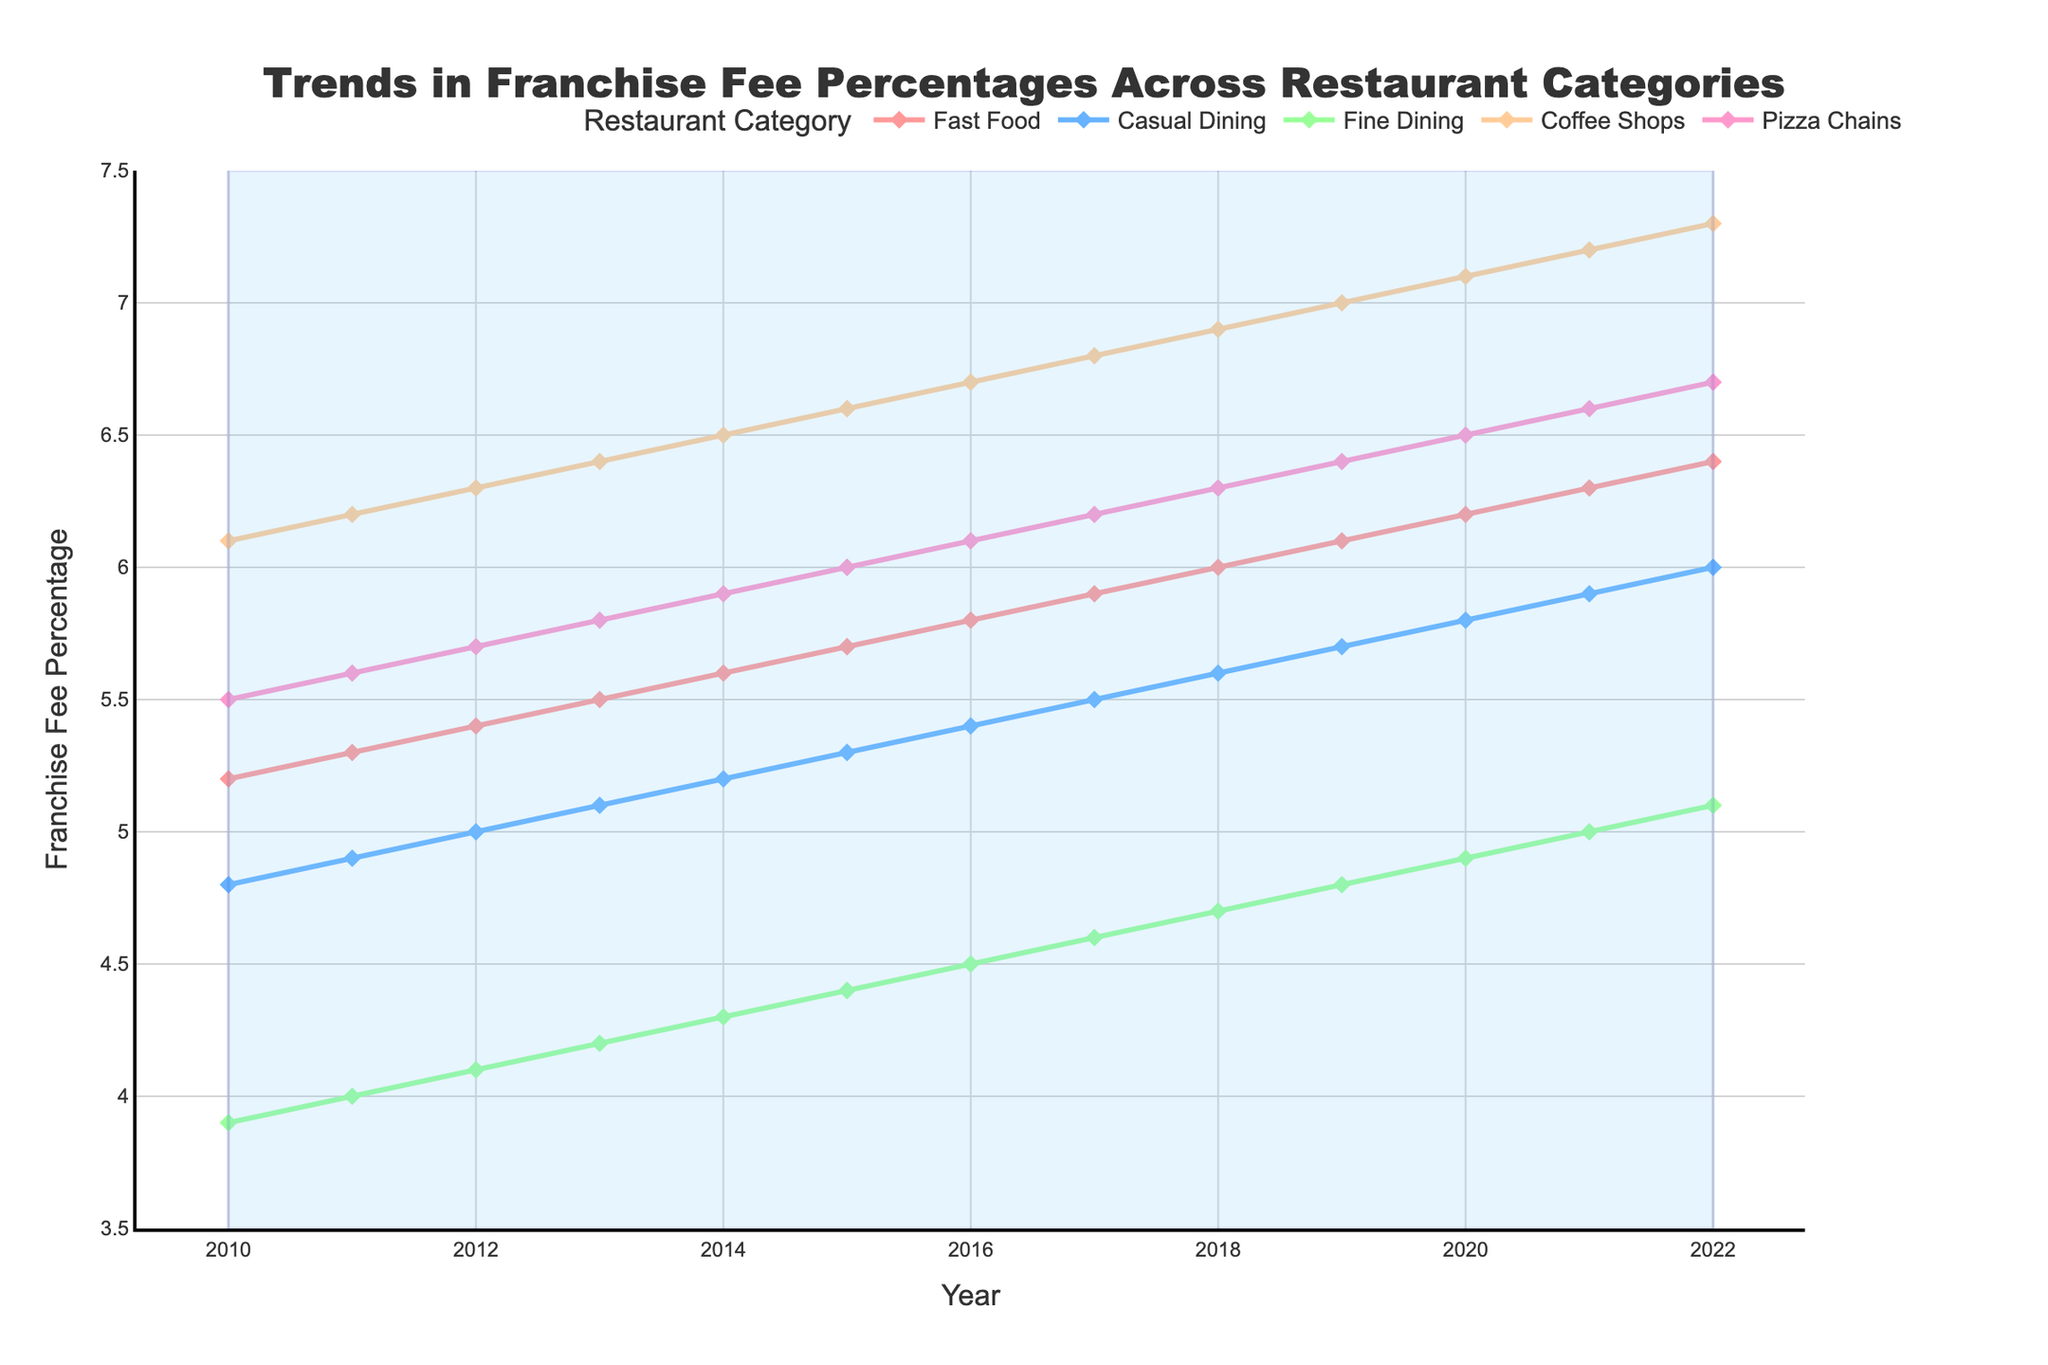What's the average franchise fee percentage for Fast Food over the years? To calculate the average franchise fee percentage for Fast Food, add up all the values for Fast Food from 2010 to 2022 and divide by the number of years. (5.2 + 5.3 + 5.4 + 5.5 + 5.6 + 5.7 + 5.8 + 5.9 + 6.0 + 6.1 + 6.2 + 6.3 + 6.4) / 13 = 5.815
Answer: 5.82 Which restaurant category had the highest franchise fee percentage in 2022? By visually inspecting the endpoint of the lines for each category in 2022, Coffee Shops had the highest value at 7.3.
Answer: Coffee Shops What's the rate of increase in franchise fee percentage for Fine Dining from 2011 to 2022? To calculate the rate of increase, subtract the value of Fine Dining in 2011 from the value in 2022, then divide by the number of years. (5.1 - 4.0) / (2022 - 2011) = 1.1 / 11 ≈ 0.1
Answer: 0.1 How does the franchise fee percentage trend for Casual Dining compare to Fast Food from 2010 to 2022? By comparing the slopes of the lines for Casual Dining and Fast Food, both show an upward trend. However, the increase in Fast Food is steeper than Casual Dining. Fast Food increases from 5.2 to 6.4 (1.2 increase), while Casual Dining increases from 4.8 to 6.0 (1.2 increase).
Answer: Fast Food increases faster Which year marks the transition where Fast Food franchise fee percentage overtakes Pizza Chains? By looking at the intersection point of the lines for Fast Food and Pizza Chains, Fast Food overtakes Pizza Chains in 2011.
Answer: 2011 What is the combined franchise fee percentage of Fine Dining and Coffee Shops in 2015? Add the franchise fee percentages of Fine Dining and Coffee Shops in the year 2015. 4.4 (Fine Dining) + 6.6 (Coffee Shops) = 11.0
Answer: 11.0 What's the average increase in franchise fee percentage for Coffee Shops per year? To find the average increase per year, subtract the value of Coffee Shops in 2010 from 2022 and divide by the number of years. (7.3 - 6.1) / (2022 - 2010) = 1.2 / 12 ≈ 0.1
Answer: 0.1 In which year did Casual Dining's franchise fee percentage reach 5.5? By examining the line for Casual Dining, the franchise fee percentage reached 5.5 in 2017.
Answer: 2017 